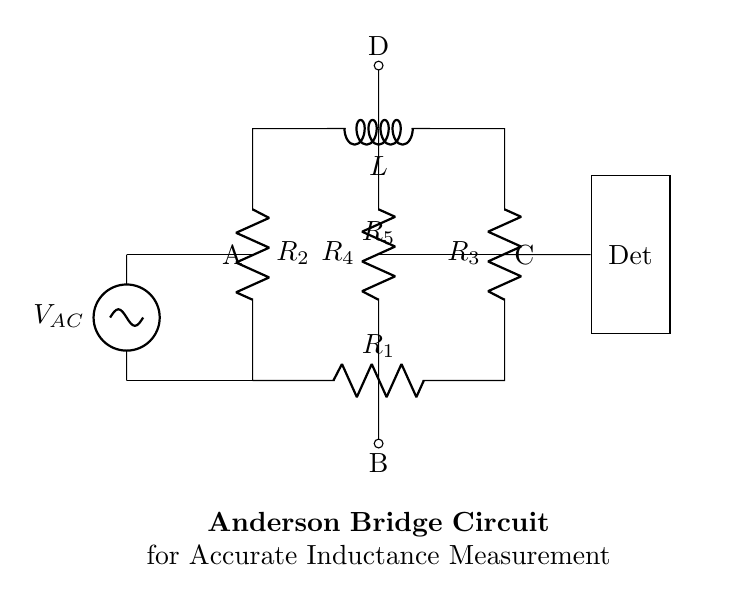What type of components are present in the circuit? The circuit contains resistors and an inductor, specifically identified as R1, R2, R3, R4, and L for the resistor and inductor components.
Answer: Resistors and an inductor What is the purpose of the AC source in this circuit? The AC source provides alternating current to the bridge, which is crucial for the operation of the Anderson bridge method of measuring inductance through the changes in balance voltage.
Answer: Measurement of inductance Which terminals are labeled with A and C? Terminal A is connected to the junction between R1 and R2, while terminal C is connected to the junction between R3 and the inductor L. These designations help identify where the measurements are taken in the circuit.
Answer: A: junction of R1 and R2; C: junction of R3 and L What is the significance of point B in this circuit? Point B is a junction connected to resistor R4. It plays a vital role in the bridge balance condition and affects the measurement accuracy of the inductance.
Answer: Junction of R4 How does the Anderson bridge achieve accuracy in inductance measurement? The accuracy is achieved by balancing the bridge through adjusting resistors and maintaining a null detector reading at point D, which indicates that the inductance has been accurately measured against the known resistances in the circuit.
Answer: By balancing the bridge What is the role of the detector in this setup? The detector measures the voltage difference across points B and D, indicating whether the bridge is balanced and therefore providing accurate inductance readings based on the circuit's condition.
Answer: Measures voltage difference 